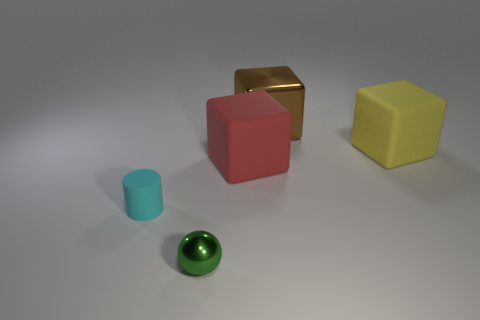Subtract all big yellow cubes. How many cubes are left? 2 Add 2 small green metal spheres. How many objects exist? 7 Subtract all spheres. How many objects are left? 4 Subtract all cyan blocks. Subtract all yellow balls. How many blocks are left? 3 Subtract 1 green spheres. How many objects are left? 4 Subtract all large gray blocks. Subtract all small cylinders. How many objects are left? 4 Add 1 tiny objects. How many tiny objects are left? 3 Add 1 large yellow matte blocks. How many large yellow matte blocks exist? 2 